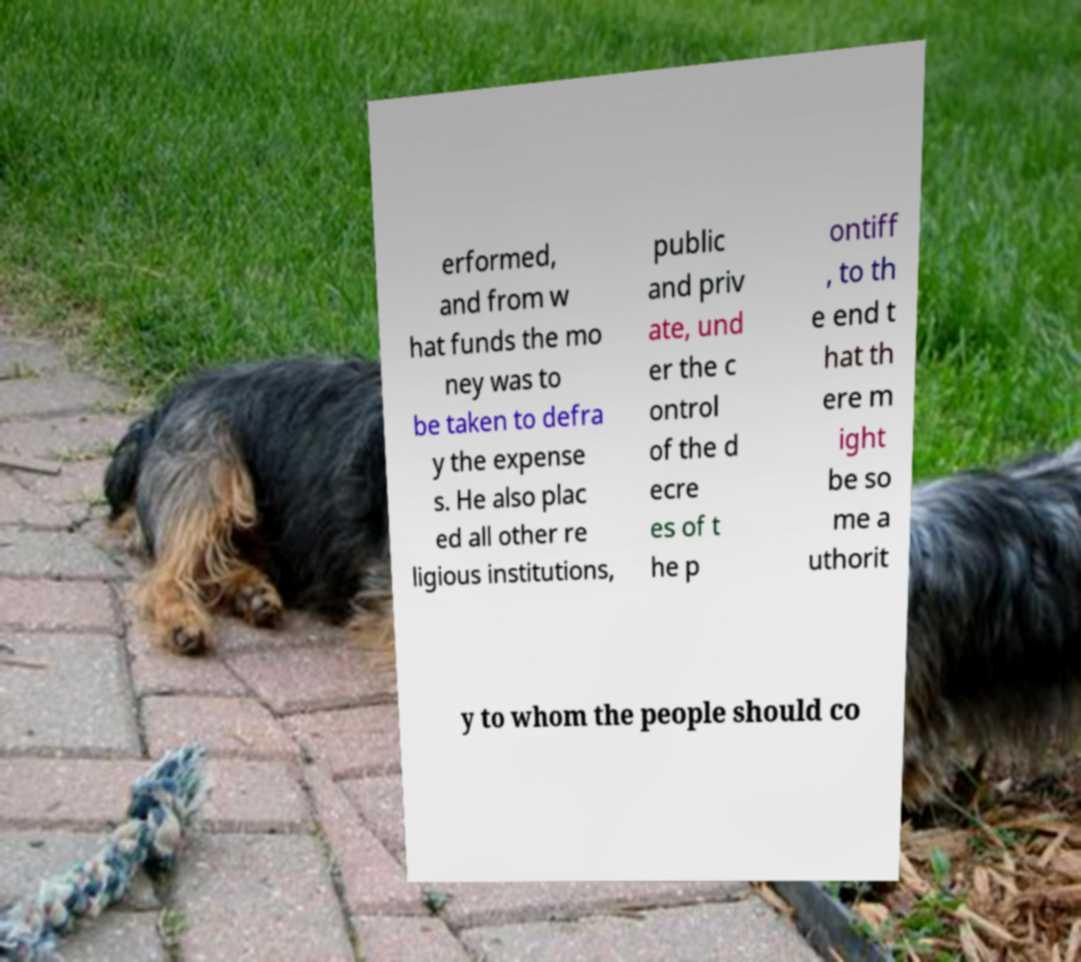Can you read and provide the text displayed in the image?This photo seems to have some interesting text. Can you extract and type it out for me? erformed, and from w hat funds the mo ney was to be taken to defra y the expense s. He also plac ed all other re ligious institutions, public and priv ate, und er the c ontrol of the d ecre es of t he p ontiff , to th e end t hat th ere m ight be so me a uthorit y to whom the people should co 